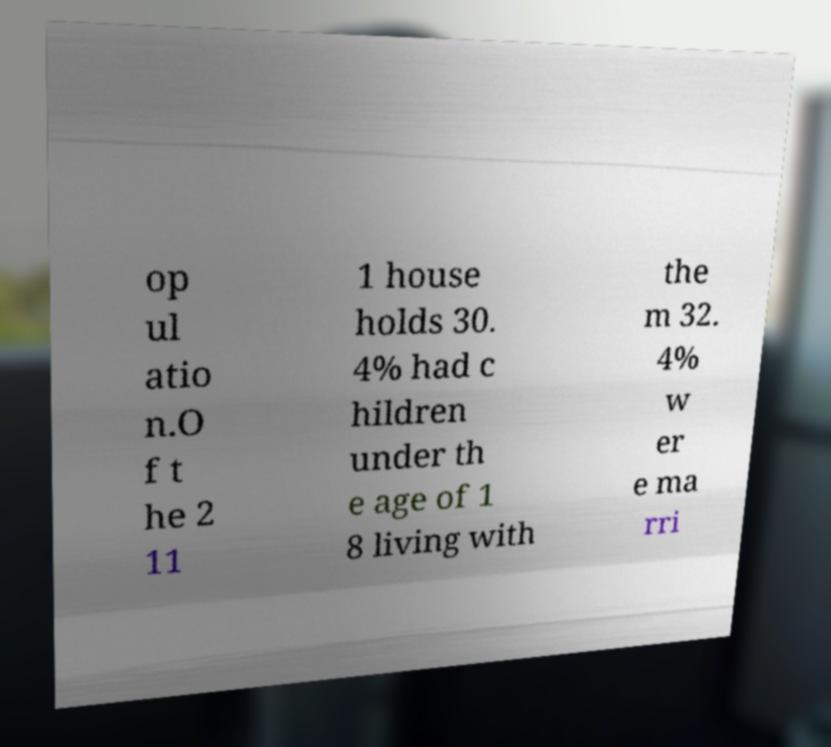There's text embedded in this image that I need extracted. Can you transcribe it verbatim? op ul atio n.O f t he 2 11 1 house holds 30. 4% had c hildren under th e age of 1 8 living with the m 32. 4% w er e ma rri 